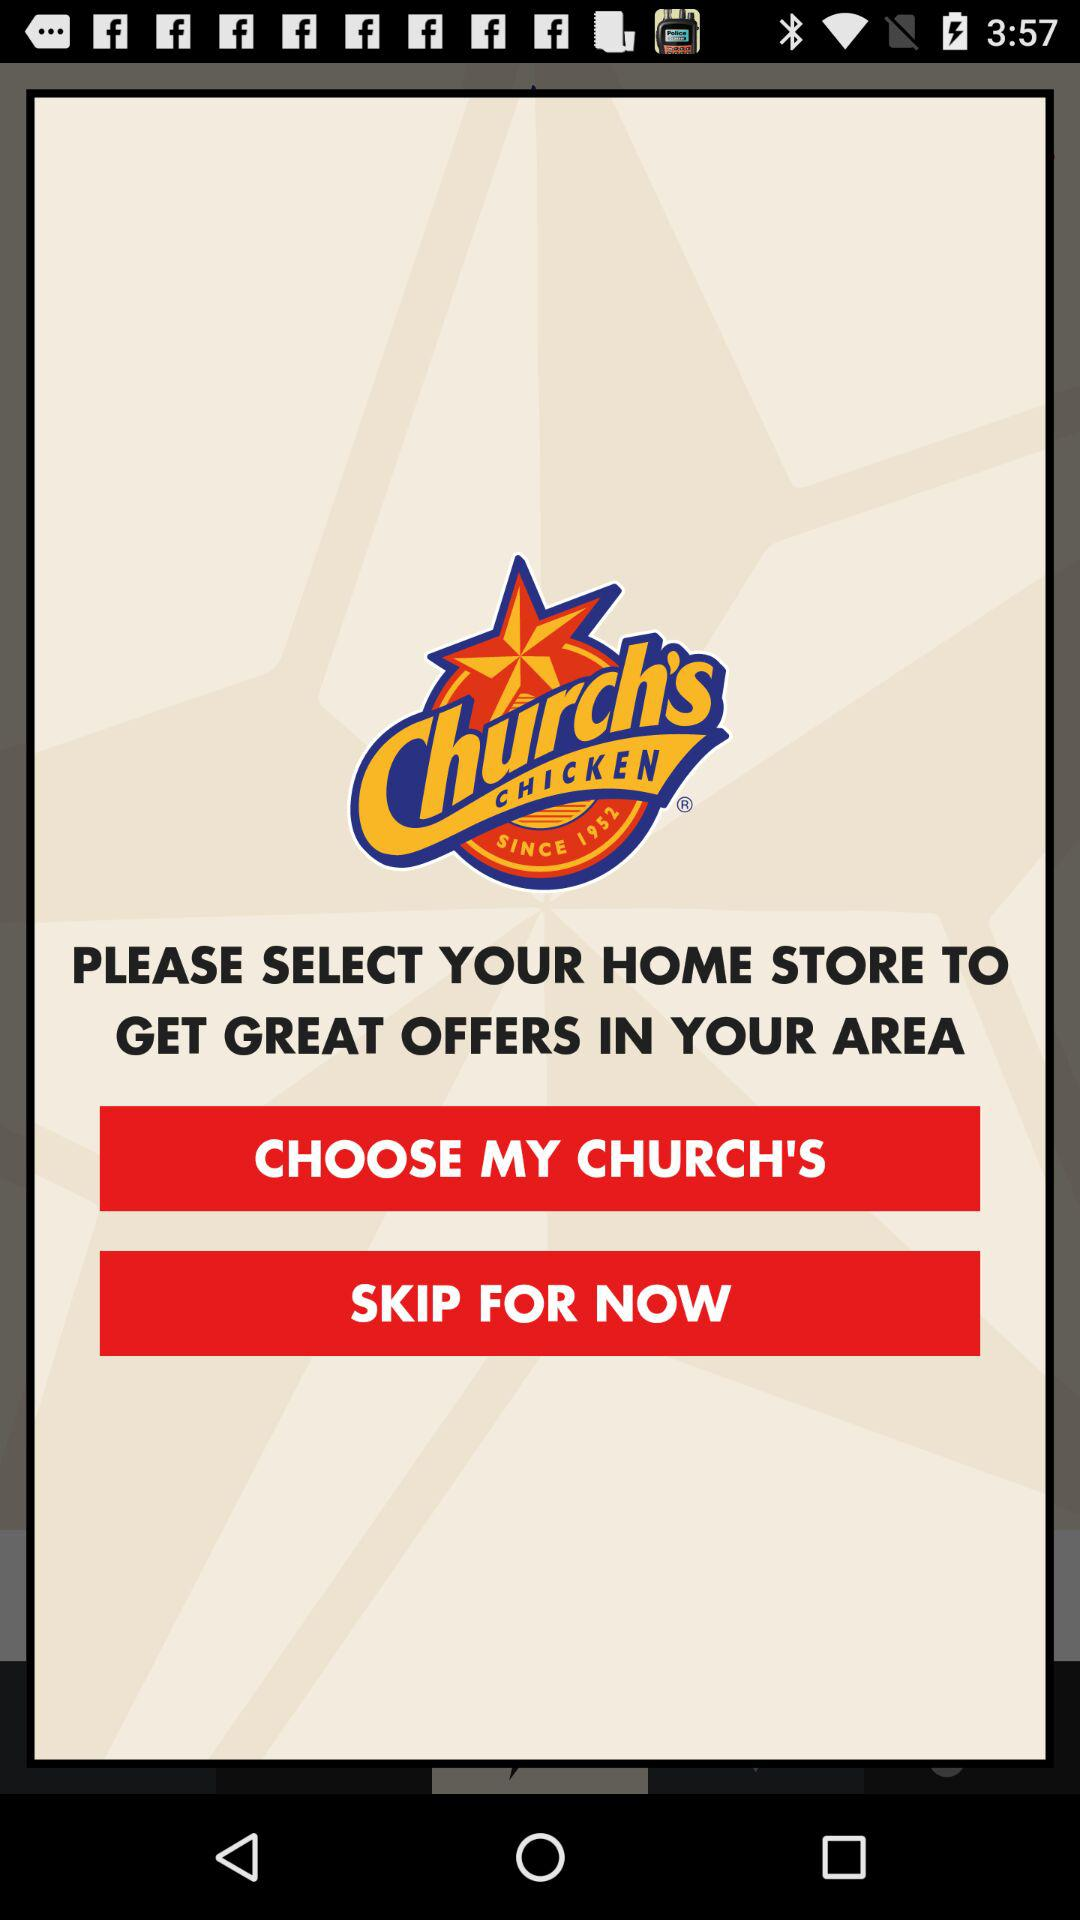What is the name of the store? The name of the store is "Church's Chicken". 